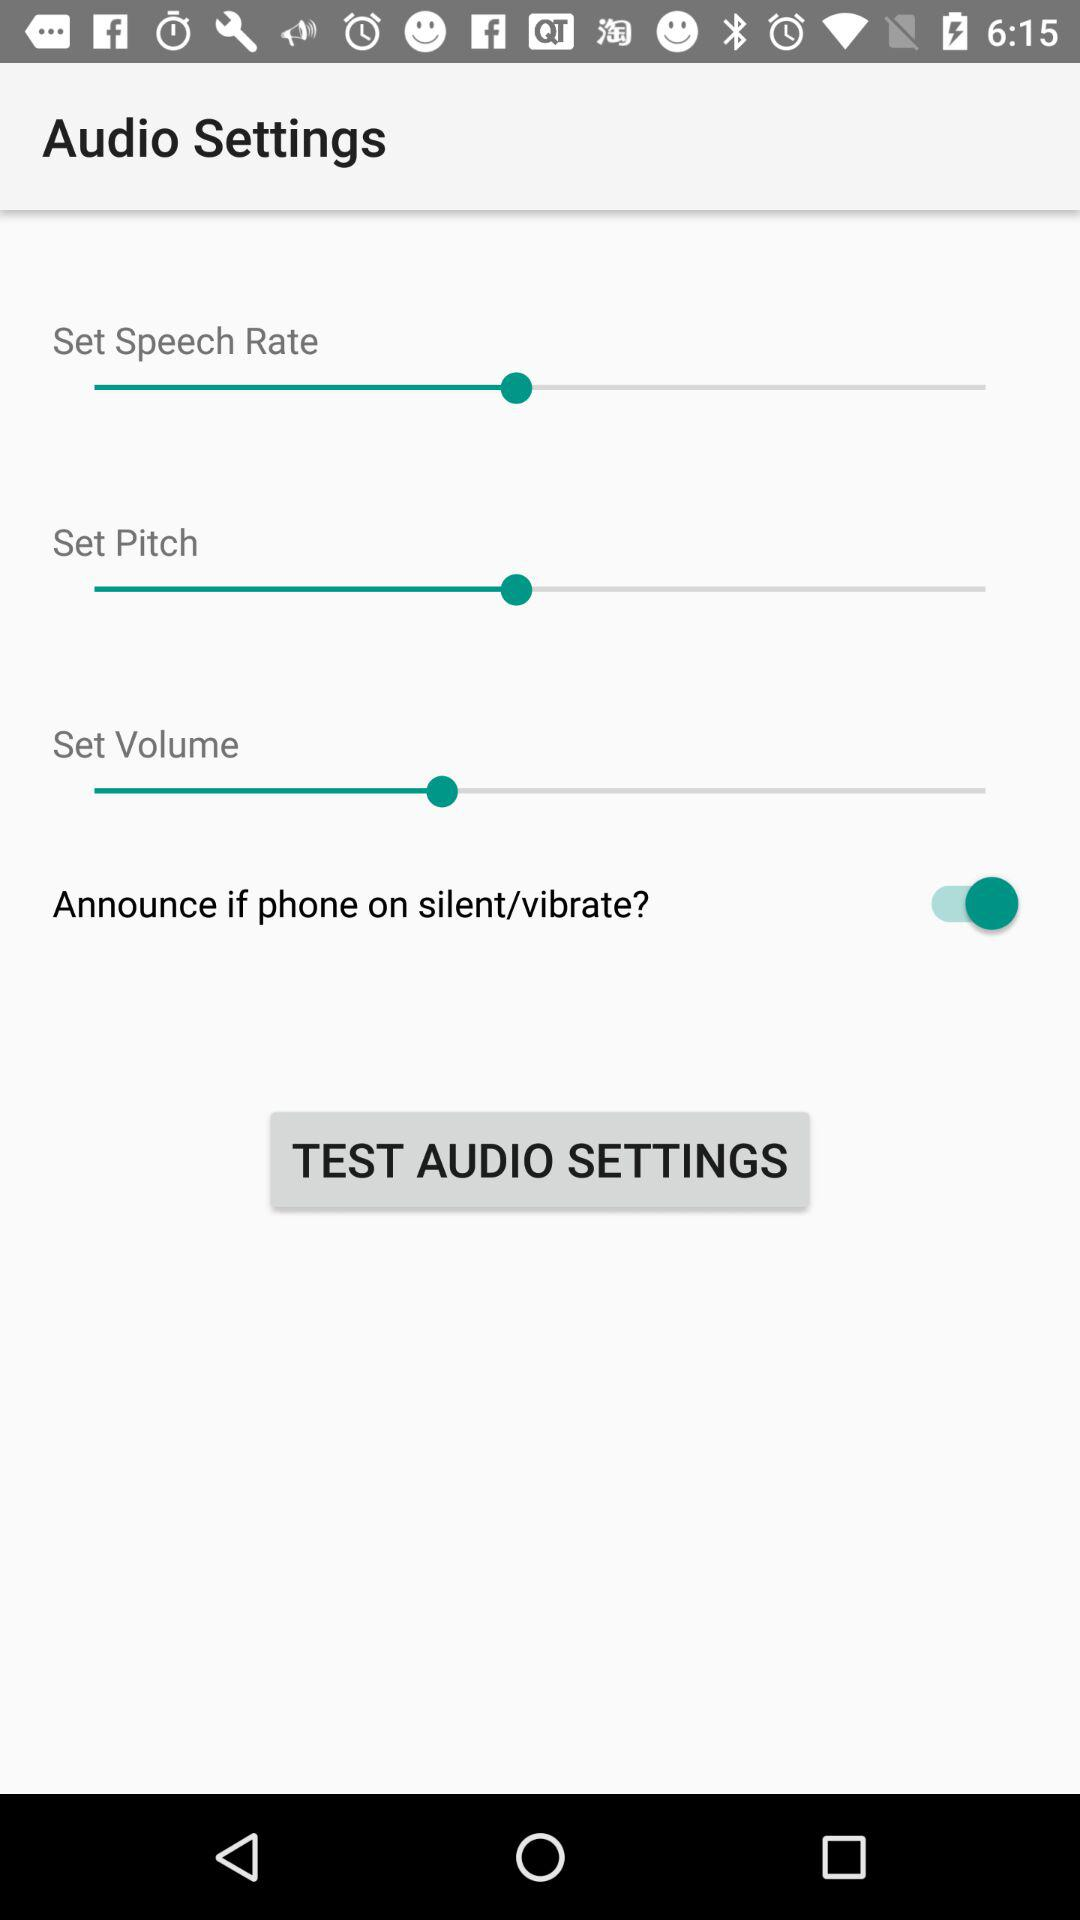What is the status of "Announce if phone on silent/vibrate"? The status is "on". 